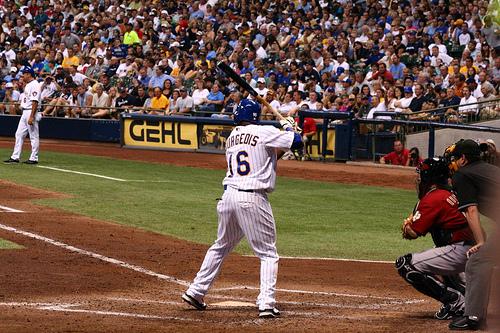What number is the batter?
Be succinct. 16. What sponsor is on the fence?
Give a very brief answer. Gehl. What is the men's Jersey number?
Write a very short answer. 16. What sport are they watching?
Short answer required. Baseball. What water brand is advertised?
Answer briefly. Gehl. What color is the batter's helmet?
Concise answer only. Blue. 